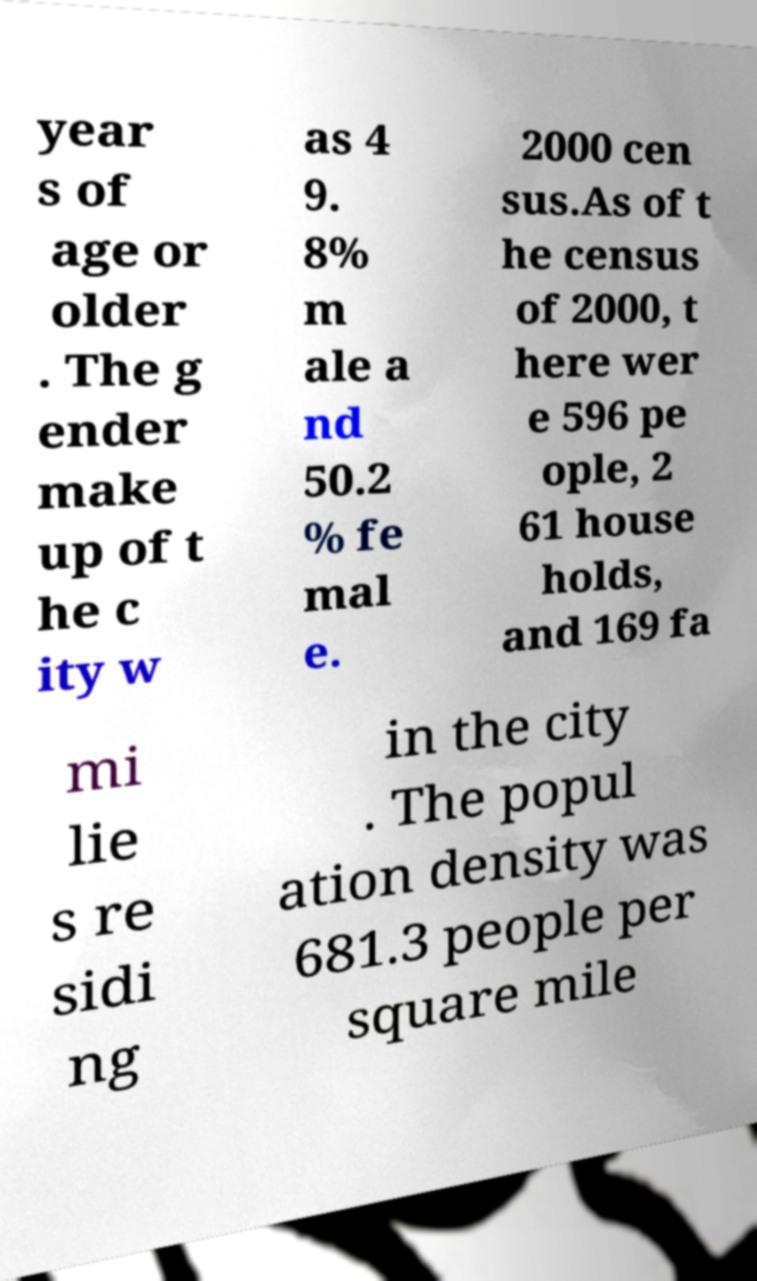There's text embedded in this image that I need extracted. Can you transcribe it verbatim? year s of age or older . The g ender make up of t he c ity w as 4 9. 8% m ale a nd 50.2 % fe mal e. 2000 cen sus.As of t he census of 2000, t here wer e 596 pe ople, 2 61 house holds, and 169 fa mi lie s re sidi ng in the city . The popul ation density was 681.3 people per square mile 